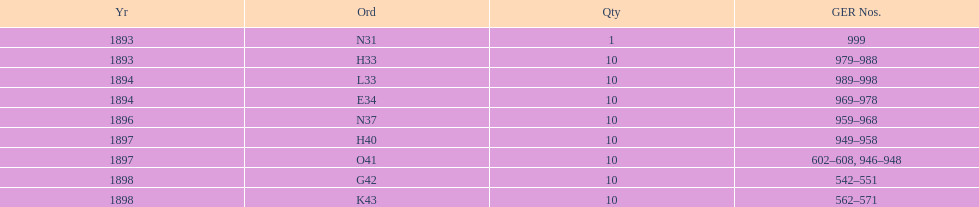What amount of time to the years span? 5 years. 